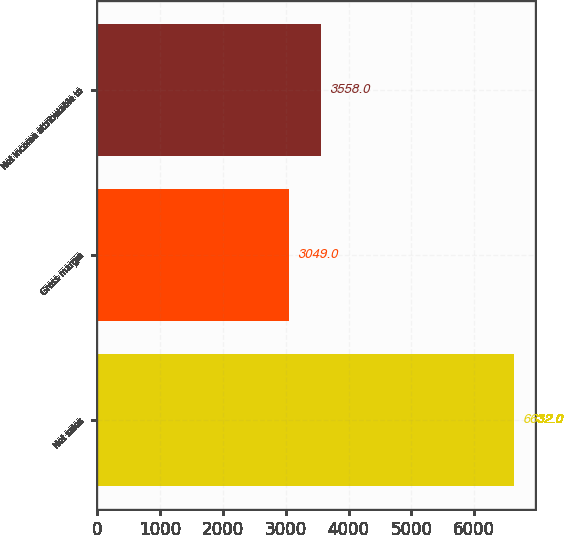Convert chart. <chart><loc_0><loc_0><loc_500><loc_500><bar_chart><fcel>Net sales<fcel>Gross margin<fcel>Net income attributable to<nl><fcel>6632<fcel>3049<fcel>3558<nl></chart> 